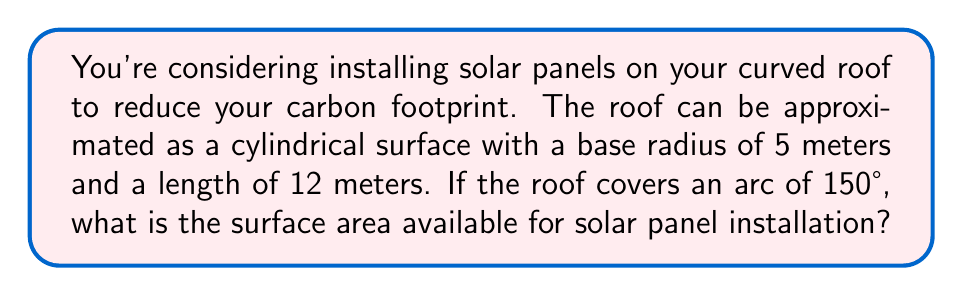Could you help me with this problem? To solve this problem, we need to use the formula for the surface area of a cylindrical segment. The steps are as follows:

1) The formula for the surface area of a cylindrical segment is:

   $$A = r \theta L$$

   Where:
   $A$ = surface area
   $r$ = radius of the cylinder base
   $\theta$ = central angle in radians
   $L$ = length of the cylinder

2) We're given the angle in degrees (150°), but we need it in radians. To convert:

   $$\theta = 150° \times \frac{\pi}{180°} = \frac{5\pi}{6} \text{ radians}$$

3) Now we can plug all the values into our formula:

   $$A = 5 \times \frac{5\pi}{6} \times 12$$

4) Simplify:

   $$A = 5 \times \frac{5\pi}{6} \times 12 = \frac{300\pi}{6} = 50\pi$$

5) Calculate the final value:

   $$A = 50\pi \approx 157.08 \text{ m}^2$$

[asy]
import geometry;

size(200);
real r = 5;
real angle = 150;

path arc = arc((0,0), r, -90, -90+angle);
draw(arc);
draw((-r,0)--(r,0), dashed);
draw((0,0)--(-r,0));
draw((0,0)--(r*cos(angle*pi/180), r*sin(angle*pi/180)));

label("$5\text{m}$", (0,-r/2), W);
label("$150°$", (r/2,r/2));

draw((r,0)--(r,12), blue);
draw((-r,0)--(-r,12), blue);
draw(arc--shift(0,12)*reverse(arc)--cycle, blue);

label("$12\text{m}$", (r,6), E);
[/asy]
Answer: The surface area available for solar panel installation is approximately 157.08 square meters. 